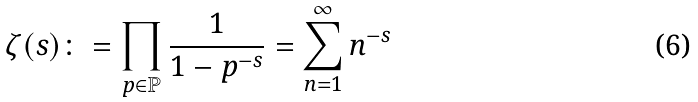<formula> <loc_0><loc_0><loc_500><loc_500>\zeta ( s ) \colon = \prod _ { p \in \mathbb { P } } \frac { 1 } { 1 - p ^ { - s } } = \sum _ { n = 1 } ^ { \infty } n ^ { - s }</formula> 